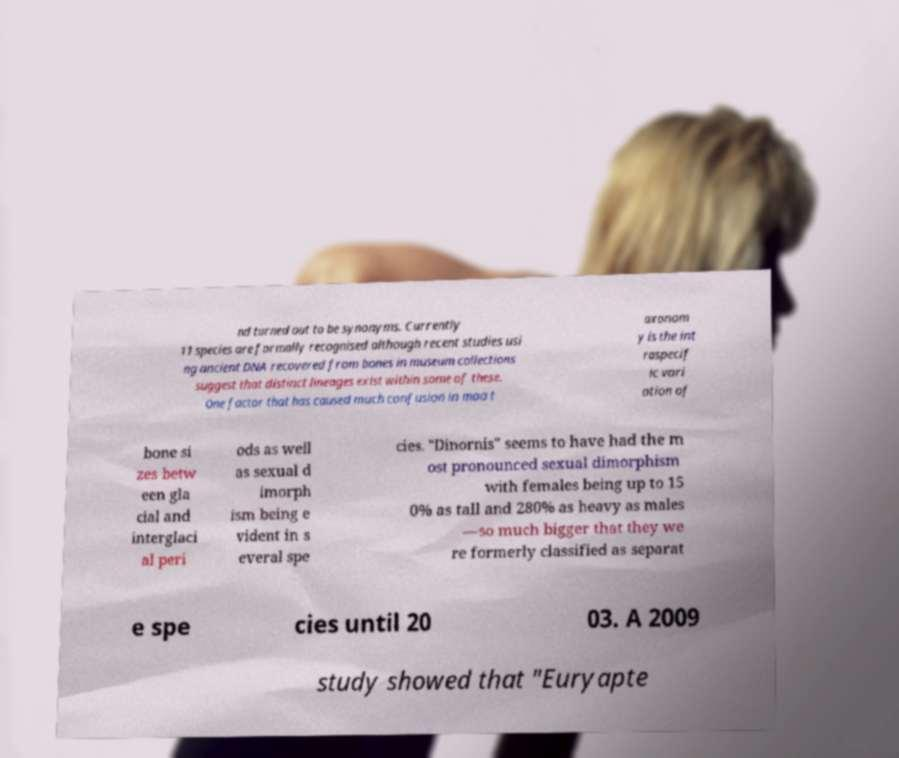Can you read and provide the text displayed in the image?This photo seems to have some interesting text. Can you extract and type it out for me? nd turned out to be synonyms. Currently 11 species are formally recognised although recent studies usi ng ancient DNA recovered from bones in museum collections suggest that distinct lineages exist within some of these. One factor that has caused much confusion in moa t axonom y is the int raspecif ic vari ation of bone si zes betw een gla cial and interglaci al peri ods as well as sexual d imorph ism being e vident in s everal spe cies. "Dinornis" seems to have had the m ost pronounced sexual dimorphism with females being up to 15 0% as tall and 280% as heavy as males —so much bigger that they we re formerly classified as separat e spe cies until 20 03. A 2009 study showed that "Euryapte 